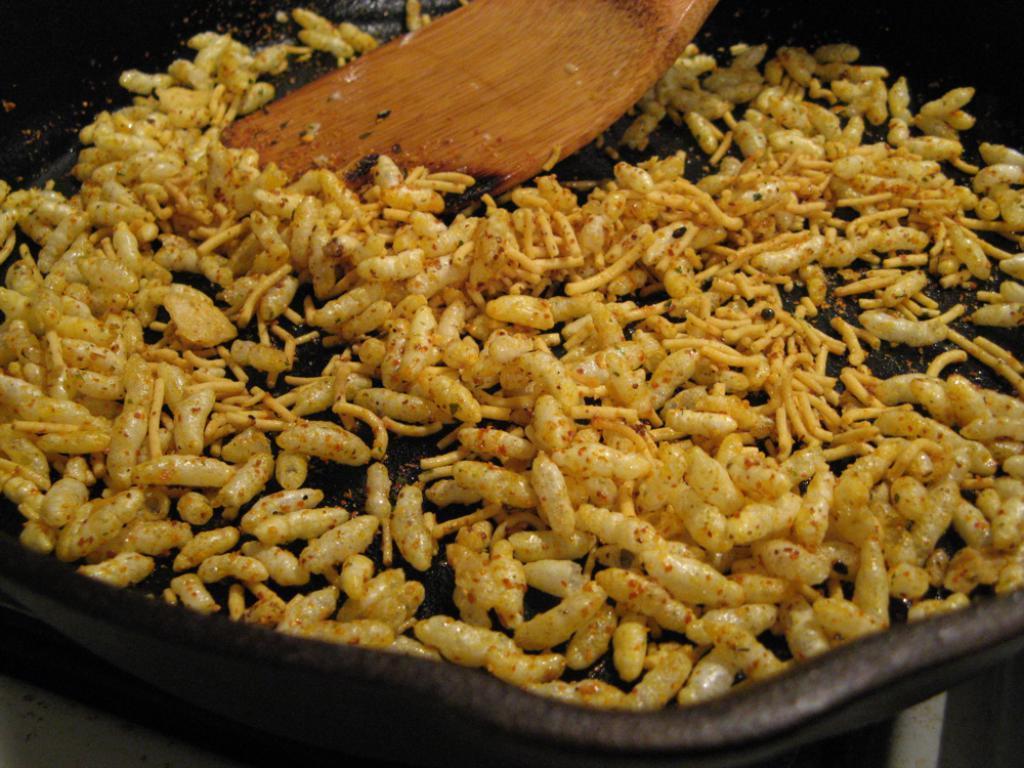Could you give a brief overview of what you see in this image? In the image there is a poha in a pan along with a wooden spoon. 